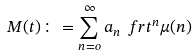Convert formula to latex. <formula><loc_0><loc_0><loc_500><loc_500>M ( t ) \colon = \sum _ { n = o } ^ { \infty } a _ { n } \ f r { t ^ { n } } { \mu ( n ) }</formula> 